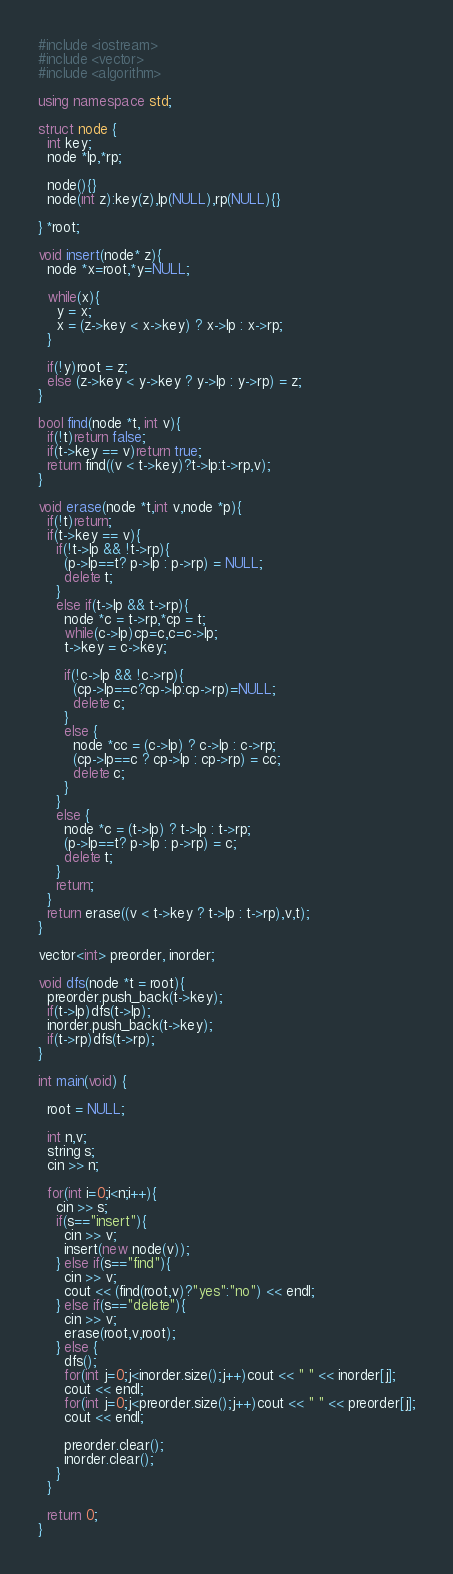Convert code to text. <code><loc_0><loc_0><loc_500><loc_500><_C++_>#include <iostream>
#include <vector>
#include <algorithm>

using namespace std;

struct node {
  int key;
  node *lp,*rp;

  node(){}
  node(int z):key(z),lp(NULL),rp(NULL){}

} *root;

void insert(node* z){
  node *x=root,*y=NULL;

  while(x){
    y = x;
    x = (z->key < x->key) ? x->lp : x->rp;
  }

  if(!y)root = z;
  else (z->key < y->key ? y->lp : y->rp) = z;
}

bool find(node *t, int v){
  if(!t)return false;
  if(t->key == v)return true;
  return find((v < t->key)?t->lp:t->rp,v);
}

void erase(node *t,int v,node *p){
  if(!t)return;
  if(t->key == v){
    if(!t->lp && !t->rp){
      (p->lp==t? p->lp : p->rp) = NULL;
      delete t;
    }
    else if(t->lp && t->rp){
      node *c = t->rp,*cp = t;
      while(c->lp)cp=c,c=c->lp;
      t->key = c->key;

      if(!c->lp && !c->rp){
        (cp->lp==c?cp->lp:cp->rp)=NULL;
        delete c;
      }
      else {
        node *cc = (c->lp) ? c->lp : c->rp;
        (cp->lp==c ? cp->lp : cp->rp) = cc;
        delete c;
      }
    }
    else {
      node *c = (t->lp) ? t->lp : t->rp;
      (p->lp==t? p->lp : p->rp) = c;
      delete t;
    }
    return;
  }
  return erase((v < t->key ? t->lp : t->rp),v,t);
}

vector<int> preorder, inorder;

void dfs(node *t = root){
  preorder.push_back(t->key);
  if(t->lp)dfs(t->lp);
  inorder.push_back(t->key);
  if(t->rp)dfs(t->rp);
}

int main(void) {

  root = NULL;

  int n,v;
  string s;
  cin >> n;

  for(int i=0;i<n;i++){
    cin >> s;
    if(s=="insert"){
      cin >> v;
      insert(new node(v));
    } else if(s=="find"){
      cin >> v;
      cout << (find(root,v)?"yes":"no") << endl;
    } else if(s=="delete"){
      cin >> v;
      erase(root,v,root);
    } else {
      dfs();
      for(int j=0;j<inorder.size();j++)cout << " " << inorder[j];
      cout << endl;
      for(int j=0;j<preorder.size();j++)cout << " " << preorder[j];
      cout << endl;

      preorder.clear();
      inorder.clear();
    }
  }

  return 0;
}</code> 